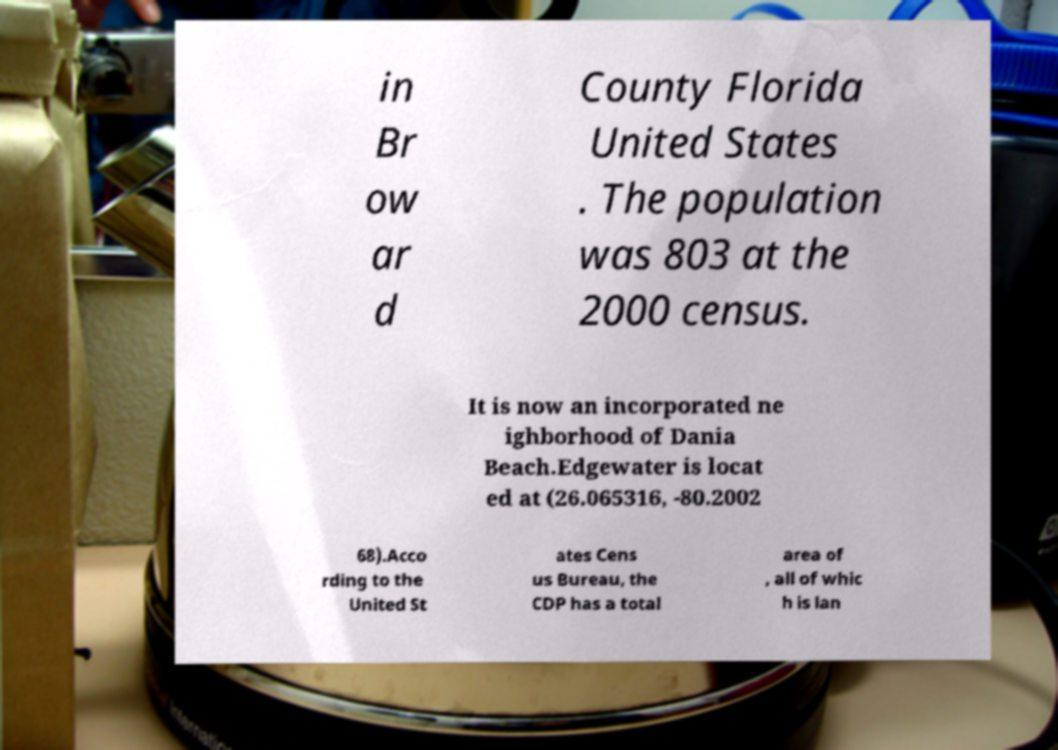Can you accurately transcribe the text from the provided image for me? in Br ow ar d County Florida United States . The population was 803 at the 2000 census. It is now an incorporated ne ighborhood of Dania Beach.Edgewater is locat ed at (26.065316, -80.2002 68).Acco rding to the United St ates Cens us Bureau, the CDP has a total area of , all of whic h is lan 